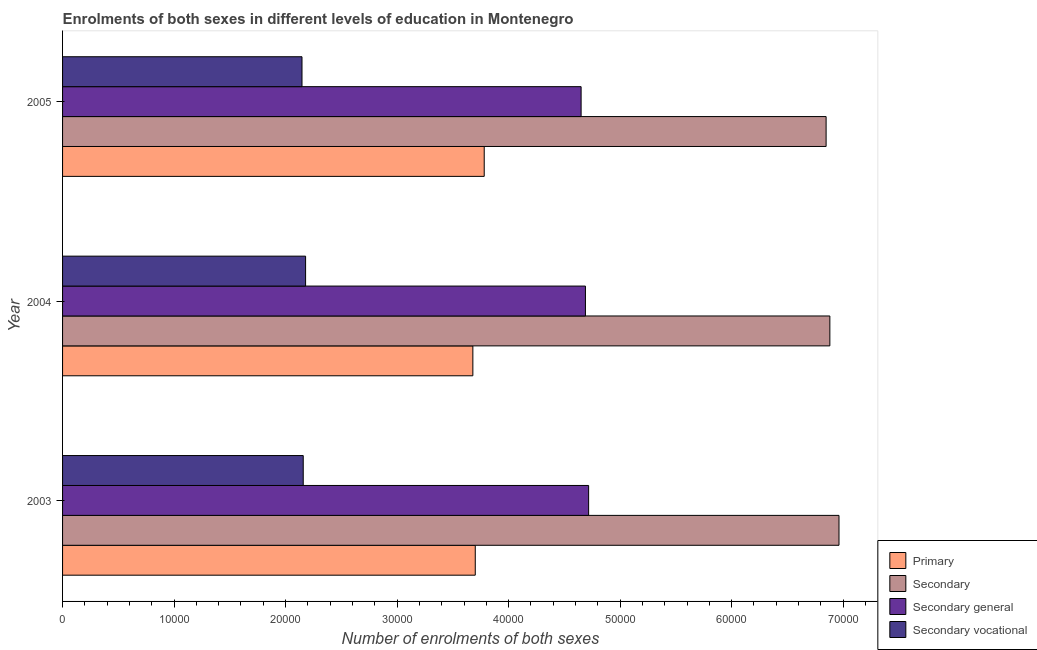How many different coloured bars are there?
Your answer should be very brief. 4. How many groups of bars are there?
Keep it short and to the point. 3. Are the number of bars per tick equal to the number of legend labels?
Ensure brevity in your answer.  Yes. What is the label of the 2nd group of bars from the top?
Provide a succinct answer. 2004. In how many cases, is the number of bars for a given year not equal to the number of legend labels?
Your answer should be very brief. 0. What is the number of enrolments in secondary vocational education in 2003?
Keep it short and to the point. 2.16e+04. Across all years, what is the maximum number of enrolments in primary education?
Your response must be concise. 3.78e+04. Across all years, what is the minimum number of enrolments in secondary vocational education?
Offer a terse response. 2.15e+04. In which year was the number of enrolments in secondary education maximum?
Your answer should be very brief. 2003. In which year was the number of enrolments in secondary education minimum?
Keep it short and to the point. 2005. What is the total number of enrolments in secondary education in the graph?
Give a very brief answer. 2.07e+05. What is the difference between the number of enrolments in secondary general education in 2003 and that in 2004?
Ensure brevity in your answer.  286. What is the difference between the number of enrolments in secondary general education in 2003 and the number of enrolments in primary education in 2004?
Provide a short and direct response. 1.04e+04. What is the average number of enrolments in secondary education per year?
Keep it short and to the point. 6.90e+04. In the year 2003, what is the difference between the number of enrolments in secondary education and number of enrolments in secondary general education?
Your answer should be very brief. 2.25e+04. In how many years, is the number of enrolments in secondary vocational education greater than 20000 ?
Provide a short and direct response. 3. What is the ratio of the number of enrolments in secondary vocational education in 2003 to that in 2005?
Provide a short and direct response. 1. Is the number of enrolments in secondary vocational education in 2004 less than that in 2005?
Keep it short and to the point. No. What is the difference between the highest and the second highest number of enrolments in secondary education?
Offer a terse response. 820. What is the difference between the highest and the lowest number of enrolments in secondary general education?
Make the answer very short. 675. What does the 2nd bar from the top in 2005 represents?
Your answer should be compact. Secondary general. What does the 2nd bar from the bottom in 2004 represents?
Offer a terse response. Secondary. How many years are there in the graph?
Offer a terse response. 3. What is the difference between two consecutive major ticks on the X-axis?
Offer a very short reply. 10000. Are the values on the major ticks of X-axis written in scientific E-notation?
Your answer should be very brief. No. Does the graph contain grids?
Offer a very short reply. No. How are the legend labels stacked?
Your answer should be compact. Vertical. What is the title of the graph?
Keep it short and to the point. Enrolments of both sexes in different levels of education in Montenegro. What is the label or title of the X-axis?
Offer a very short reply. Number of enrolments of both sexes. What is the label or title of the Y-axis?
Keep it short and to the point. Year. What is the Number of enrolments of both sexes in Primary in 2003?
Your answer should be compact. 3.70e+04. What is the Number of enrolments of both sexes of Secondary in 2003?
Offer a very short reply. 6.96e+04. What is the Number of enrolments of both sexes of Secondary general in 2003?
Provide a short and direct response. 4.72e+04. What is the Number of enrolments of both sexes of Secondary vocational in 2003?
Your answer should be compact. 2.16e+04. What is the Number of enrolments of both sexes in Primary in 2004?
Your response must be concise. 3.68e+04. What is the Number of enrolments of both sexes in Secondary in 2004?
Provide a short and direct response. 6.88e+04. What is the Number of enrolments of both sexes of Secondary general in 2004?
Provide a succinct answer. 4.69e+04. What is the Number of enrolments of both sexes of Secondary vocational in 2004?
Provide a short and direct response. 2.18e+04. What is the Number of enrolments of both sexes in Primary in 2005?
Your response must be concise. 3.78e+04. What is the Number of enrolments of both sexes of Secondary in 2005?
Offer a very short reply. 6.85e+04. What is the Number of enrolments of both sexes of Secondary general in 2005?
Your answer should be compact. 4.65e+04. What is the Number of enrolments of both sexes of Secondary vocational in 2005?
Offer a very short reply. 2.15e+04. Across all years, what is the maximum Number of enrolments of both sexes of Primary?
Ensure brevity in your answer.  3.78e+04. Across all years, what is the maximum Number of enrolments of both sexes of Secondary?
Give a very brief answer. 6.96e+04. Across all years, what is the maximum Number of enrolments of both sexes in Secondary general?
Your answer should be very brief. 4.72e+04. Across all years, what is the maximum Number of enrolments of both sexes of Secondary vocational?
Provide a succinct answer. 2.18e+04. Across all years, what is the minimum Number of enrolments of both sexes in Primary?
Your response must be concise. 3.68e+04. Across all years, what is the minimum Number of enrolments of both sexes of Secondary?
Your answer should be very brief. 6.85e+04. Across all years, what is the minimum Number of enrolments of both sexes of Secondary general?
Your answer should be very brief. 4.65e+04. Across all years, what is the minimum Number of enrolments of both sexes in Secondary vocational?
Offer a very short reply. 2.15e+04. What is the total Number of enrolments of both sexes in Primary in the graph?
Provide a succinct answer. 1.12e+05. What is the total Number of enrolments of both sexes in Secondary in the graph?
Your answer should be compact. 2.07e+05. What is the total Number of enrolments of both sexes of Secondary general in the graph?
Make the answer very short. 1.41e+05. What is the total Number of enrolments of both sexes of Secondary vocational in the graph?
Offer a very short reply. 6.48e+04. What is the difference between the Number of enrolments of both sexes of Primary in 2003 and that in 2004?
Offer a terse response. 216. What is the difference between the Number of enrolments of both sexes of Secondary in 2003 and that in 2004?
Give a very brief answer. 820. What is the difference between the Number of enrolments of both sexes of Secondary general in 2003 and that in 2004?
Offer a very short reply. 286. What is the difference between the Number of enrolments of both sexes of Secondary vocational in 2003 and that in 2004?
Your response must be concise. -212. What is the difference between the Number of enrolments of both sexes of Primary in 2003 and that in 2005?
Keep it short and to the point. -803. What is the difference between the Number of enrolments of both sexes in Secondary in 2003 and that in 2005?
Make the answer very short. 1156. What is the difference between the Number of enrolments of both sexes in Secondary general in 2003 and that in 2005?
Provide a short and direct response. 675. What is the difference between the Number of enrolments of both sexes of Secondary vocational in 2003 and that in 2005?
Provide a short and direct response. 111. What is the difference between the Number of enrolments of both sexes of Primary in 2004 and that in 2005?
Your response must be concise. -1019. What is the difference between the Number of enrolments of both sexes of Secondary in 2004 and that in 2005?
Offer a terse response. 336. What is the difference between the Number of enrolments of both sexes in Secondary general in 2004 and that in 2005?
Provide a short and direct response. 389. What is the difference between the Number of enrolments of both sexes in Secondary vocational in 2004 and that in 2005?
Your answer should be very brief. 323. What is the difference between the Number of enrolments of both sexes in Primary in 2003 and the Number of enrolments of both sexes in Secondary in 2004?
Keep it short and to the point. -3.18e+04. What is the difference between the Number of enrolments of both sexes in Primary in 2003 and the Number of enrolments of both sexes in Secondary general in 2004?
Ensure brevity in your answer.  -9880. What is the difference between the Number of enrolments of both sexes of Primary in 2003 and the Number of enrolments of both sexes of Secondary vocational in 2004?
Offer a very short reply. 1.52e+04. What is the difference between the Number of enrolments of both sexes in Secondary in 2003 and the Number of enrolments of both sexes in Secondary general in 2004?
Provide a succinct answer. 2.27e+04. What is the difference between the Number of enrolments of both sexes of Secondary in 2003 and the Number of enrolments of both sexes of Secondary vocational in 2004?
Keep it short and to the point. 4.78e+04. What is the difference between the Number of enrolments of both sexes of Secondary general in 2003 and the Number of enrolments of both sexes of Secondary vocational in 2004?
Offer a very short reply. 2.54e+04. What is the difference between the Number of enrolments of both sexes of Primary in 2003 and the Number of enrolments of both sexes of Secondary in 2005?
Make the answer very short. -3.15e+04. What is the difference between the Number of enrolments of both sexes of Primary in 2003 and the Number of enrolments of both sexes of Secondary general in 2005?
Ensure brevity in your answer.  -9491. What is the difference between the Number of enrolments of both sexes of Primary in 2003 and the Number of enrolments of both sexes of Secondary vocational in 2005?
Provide a succinct answer. 1.55e+04. What is the difference between the Number of enrolments of both sexes of Secondary in 2003 and the Number of enrolments of both sexes of Secondary general in 2005?
Keep it short and to the point. 2.31e+04. What is the difference between the Number of enrolments of both sexes in Secondary in 2003 and the Number of enrolments of both sexes in Secondary vocational in 2005?
Provide a short and direct response. 4.82e+04. What is the difference between the Number of enrolments of both sexes of Secondary general in 2003 and the Number of enrolments of both sexes of Secondary vocational in 2005?
Provide a succinct answer. 2.57e+04. What is the difference between the Number of enrolments of both sexes of Primary in 2004 and the Number of enrolments of both sexes of Secondary in 2005?
Make the answer very short. -3.17e+04. What is the difference between the Number of enrolments of both sexes in Primary in 2004 and the Number of enrolments of both sexes in Secondary general in 2005?
Your response must be concise. -9707. What is the difference between the Number of enrolments of both sexes of Primary in 2004 and the Number of enrolments of both sexes of Secondary vocational in 2005?
Offer a very short reply. 1.53e+04. What is the difference between the Number of enrolments of both sexes in Secondary in 2004 and the Number of enrolments of both sexes in Secondary general in 2005?
Make the answer very short. 2.23e+04. What is the difference between the Number of enrolments of both sexes of Secondary in 2004 and the Number of enrolments of both sexes of Secondary vocational in 2005?
Make the answer very short. 4.73e+04. What is the difference between the Number of enrolments of both sexes of Secondary general in 2004 and the Number of enrolments of both sexes of Secondary vocational in 2005?
Your answer should be compact. 2.54e+04. What is the average Number of enrolments of both sexes of Primary per year?
Offer a very short reply. 3.72e+04. What is the average Number of enrolments of both sexes of Secondary per year?
Offer a very short reply. 6.90e+04. What is the average Number of enrolments of both sexes of Secondary general per year?
Offer a very short reply. 4.69e+04. What is the average Number of enrolments of both sexes in Secondary vocational per year?
Keep it short and to the point. 2.16e+04. In the year 2003, what is the difference between the Number of enrolments of both sexes of Primary and Number of enrolments of both sexes of Secondary?
Ensure brevity in your answer.  -3.26e+04. In the year 2003, what is the difference between the Number of enrolments of both sexes in Primary and Number of enrolments of both sexes in Secondary general?
Make the answer very short. -1.02e+04. In the year 2003, what is the difference between the Number of enrolments of both sexes in Primary and Number of enrolments of both sexes in Secondary vocational?
Your answer should be compact. 1.54e+04. In the year 2003, what is the difference between the Number of enrolments of both sexes of Secondary and Number of enrolments of both sexes of Secondary general?
Provide a short and direct response. 2.25e+04. In the year 2003, what is the difference between the Number of enrolments of both sexes in Secondary and Number of enrolments of both sexes in Secondary vocational?
Your answer should be compact. 4.80e+04. In the year 2003, what is the difference between the Number of enrolments of both sexes of Secondary general and Number of enrolments of both sexes of Secondary vocational?
Ensure brevity in your answer.  2.56e+04. In the year 2004, what is the difference between the Number of enrolments of both sexes of Primary and Number of enrolments of both sexes of Secondary?
Ensure brevity in your answer.  -3.20e+04. In the year 2004, what is the difference between the Number of enrolments of both sexes in Primary and Number of enrolments of both sexes in Secondary general?
Your answer should be very brief. -1.01e+04. In the year 2004, what is the difference between the Number of enrolments of both sexes in Primary and Number of enrolments of both sexes in Secondary vocational?
Your response must be concise. 1.50e+04. In the year 2004, what is the difference between the Number of enrolments of both sexes in Secondary and Number of enrolments of both sexes in Secondary general?
Provide a short and direct response. 2.19e+04. In the year 2004, what is the difference between the Number of enrolments of both sexes in Secondary and Number of enrolments of both sexes in Secondary vocational?
Keep it short and to the point. 4.70e+04. In the year 2004, what is the difference between the Number of enrolments of both sexes in Secondary general and Number of enrolments of both sexes in Secondary vocational?
Offer a terse response. 2.51e+04. In the year 2005, what is the difference between the Number of enrolments of both sexes in Primary and Number of enrolments of both sexes in Secondary?
Provide a succinct answer. -3.07e+04. In the year 2005, what is the difference between the Number of enrolments of both sexes of Primary and Number of enrolments of both sexes of Secondary general?
Your answer should be very brief. -8688. In the year 2005, what is the difference between the Number of enrolments of both sexes of Primary and Number of enrolments of both sexes of Secondary vocational?
Give a very brief answer. 1.63e+04. In the year 2005, what is the difference between the Number of enrolments of both sexes in Secondary and Number of enrolments of both sexes in Secondary general?
Offer a very short reply. 2.20e+04. In the year 2005, what is the difference between the Number of enrolments of both sexes in Secondary and Number of enrolments of both sexes in Secondary vocational?
Your response must be concise. 4.70e+04. In the year 2005, what is the difference between the Number of enrolments of both sexes in Secondary general and Number of enrolments of both sexes in Secondary vocational?
Make the answer very short. 2.50e+04. What is the ratio of the Number of enrolments of both sexes of Primary in 2003 to that in 2004?
Your answer should be compact. 1.01. What is the ratio of the Number of enrolments of both sexes of Secondary in 2003 to that in 2004?
Keep it short and to the point. 1.01. What is the ratio of the Number of enrolments of both sexes in Secondary vocational in 2003 to that in 2004?
Your answer should be very brief. 0.99. What is the ratio of the Number of enrolments of both sexes in Primary in 2003 to that in 2005?
Your response must be concise. 0.98. What is the ratio of the Number of enrolments of both sexes of Secondary in 2003 to that in 2005?
Provide a short and direct response. 1.02. What is the ratio of the Number of enrolments of both sexes of Secondary general in 2003 to that in 2005?
Provide a succinct answer. 1.01. What is the ratio of the Number of enrolments of both sexes in Primary in 2004 to that in 2005?
Ensure brevity in your answer.  0.97. What is the ratio of the Number of enrolments of both sexes in Secondary in 2004 to that in 2005?
Offer a terse response. 1. What is the ratio of the Number of enrolments of both sexes in Secondary general in 2004 to that in 2005?
Your answer should be very brief. 1.01. What is the ratio of the Number of enrolments of both sexes of Secondary vocational in 2004 to that in 2005?
Make the answer very short. 1.01. What is the difference between the highest and the second highest Number of enrolments of both sexes in Primary?
Your response must be concise. 803. What is the difference between the highest and the second highest Number of enrolments of both sexes of Secondary?
Offer a terse response. 820. What is the difference between the highest and the second highest Number of enrolments of both sexes in Secondary general?
Give a very brief answer. 286. What is the difference between the highest and the second highest Number of enrolments of both sexes in Secondary vocational?
Your answer should be very brief. 212. What is the difference between the highest and the lowest Number of enrolments of both sexes in Primary?
Make the answer very short. 1019. What is the difference between the highest and the lowest Number of enrolments of both sexes of Secondary?
Provide a short and direct response. 1156. What is the difference between the highest and the lowest Number of enrolments of both sexes of Secondary general?
Provide a short and direct response. 675. What is the difference between the highest and the lowest Number of enrolments of both sexes in Secondary vocational?
Offer a very short reply. 323. 